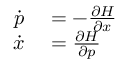<formula> <loc_0><loc_0><loc_500><loc_500>\begin{array} { r l } { { \dot { p } } } & = - { \frac { \partial H } { \partial x } } } \\ { { \dot { x } } } & = { \frac { \partial H } { \partial p } } } \end{array}</formula> 